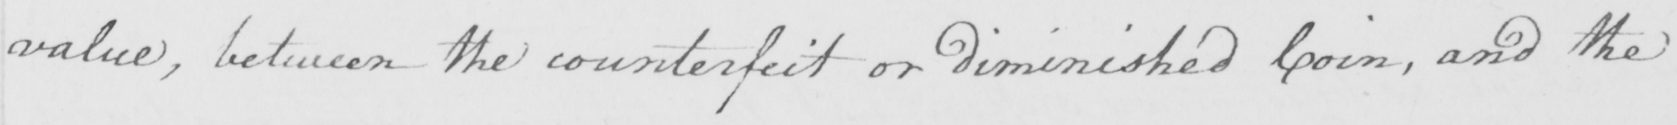What is written in this line of handwriting? value , between the counterfeit or diminished Coin , and the 